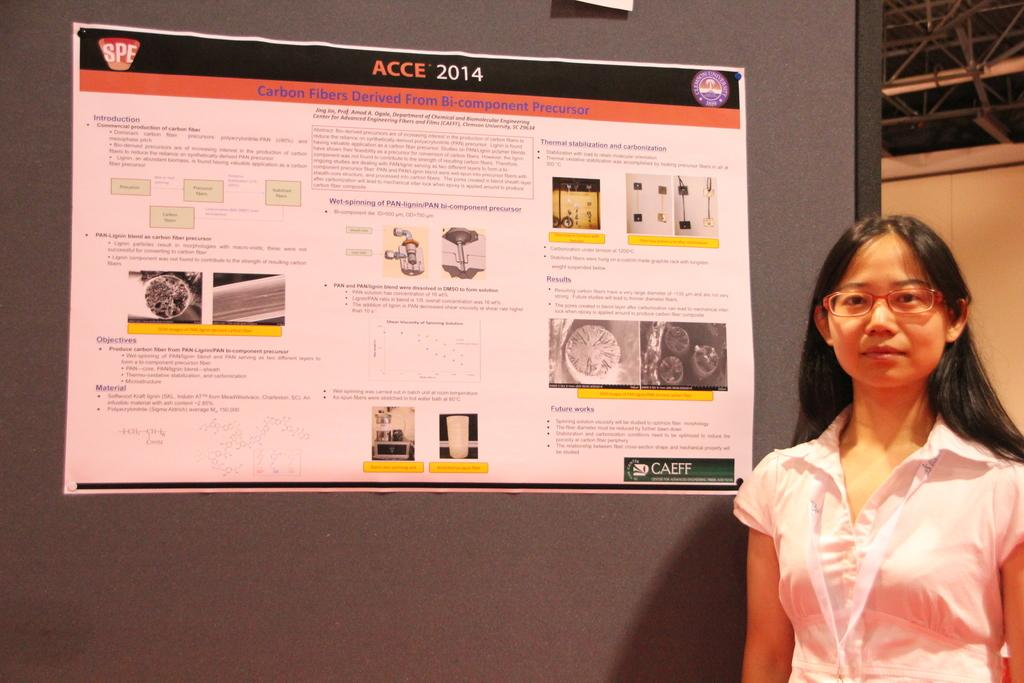What is on the platform in the image? There is a poster on a platform in the image. Where is the woman located in the image? The woman is on the right side of the image. What can be seen in the background of the image? There are poles and a wall in the background of the image. How many clocks are hanging from the poles in the image? There are no clocks visible in the image; only poles and a wall can be seen in the background. What type of crate is being used to store the poster in the image? There is no crate present in the image; the poster is on a platform. 